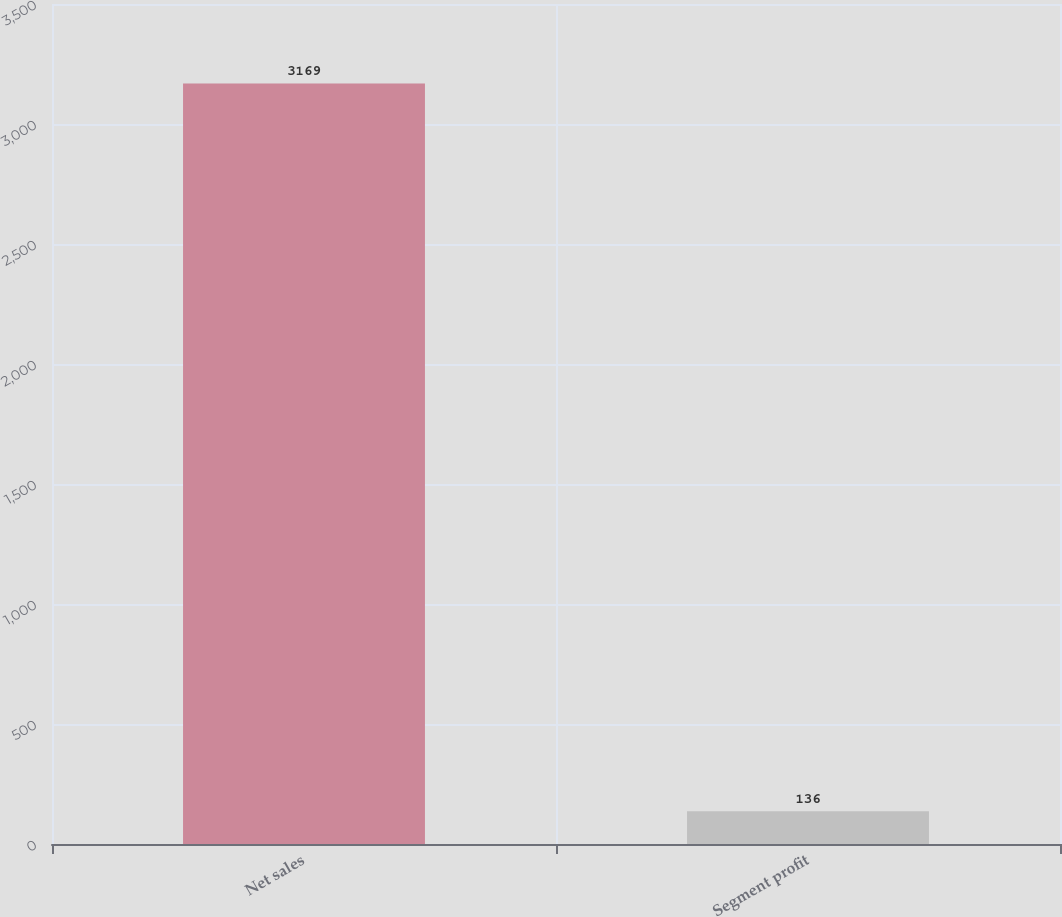Convert chart to OTSL. <chart><loc_0><loc_0><loc_500><loc_500><bar_chart><fcel>Net sales<fcel>Segment profit<nl><fcel>3169<fcel>136<nl></chart> 